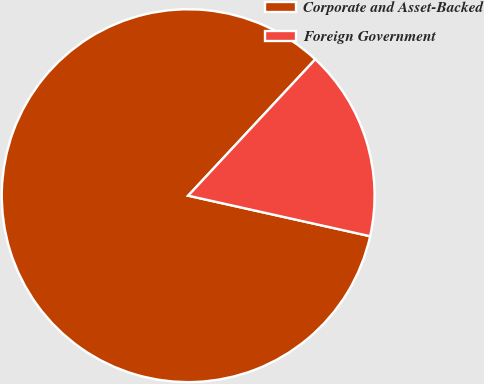Convert chart to OTSL. <chart><loc_0><loc_0><loc_500><loc_500><pie_chart><fcel>Corporate and Asset-Backed<fcel>Foreign Government<nl><fcel>83.45%<fcel>16.55%<nl></chart> 